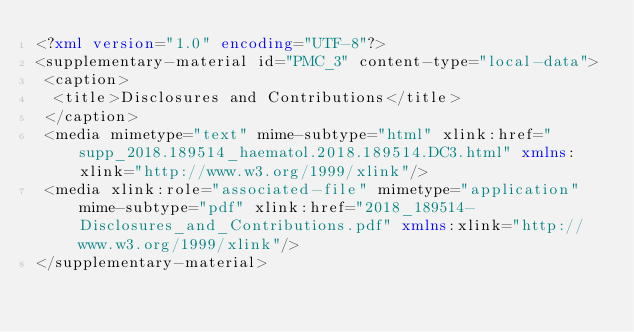Convert code to text. <code><loc_0><loc_0><loc_500><loc_500><_XML_><?xml version="1.0" encoding="UTF-8"?>
<supplementary-material id="PMC_3" content-type="local-data">
 <caption>
  <title>Disclosures and Contributions</title>
 </caption>
 <media mimetype="text" mime-subtype="html" xlink:href="supp_2018.189514_haematol.2018.189514.DC3.html" xmlns:xlink="http://www.w3.org/1999/xlink"/>
 <media xlink:role="associated-file" mimetype="application" mime-subtype="pdf" xlink:href="2018_189514-Disclosures_and_Contributions.pdf" xmlns:xlink="http://www.w3.org/1999/xlink"/>
</supplementary-material>
</code> 